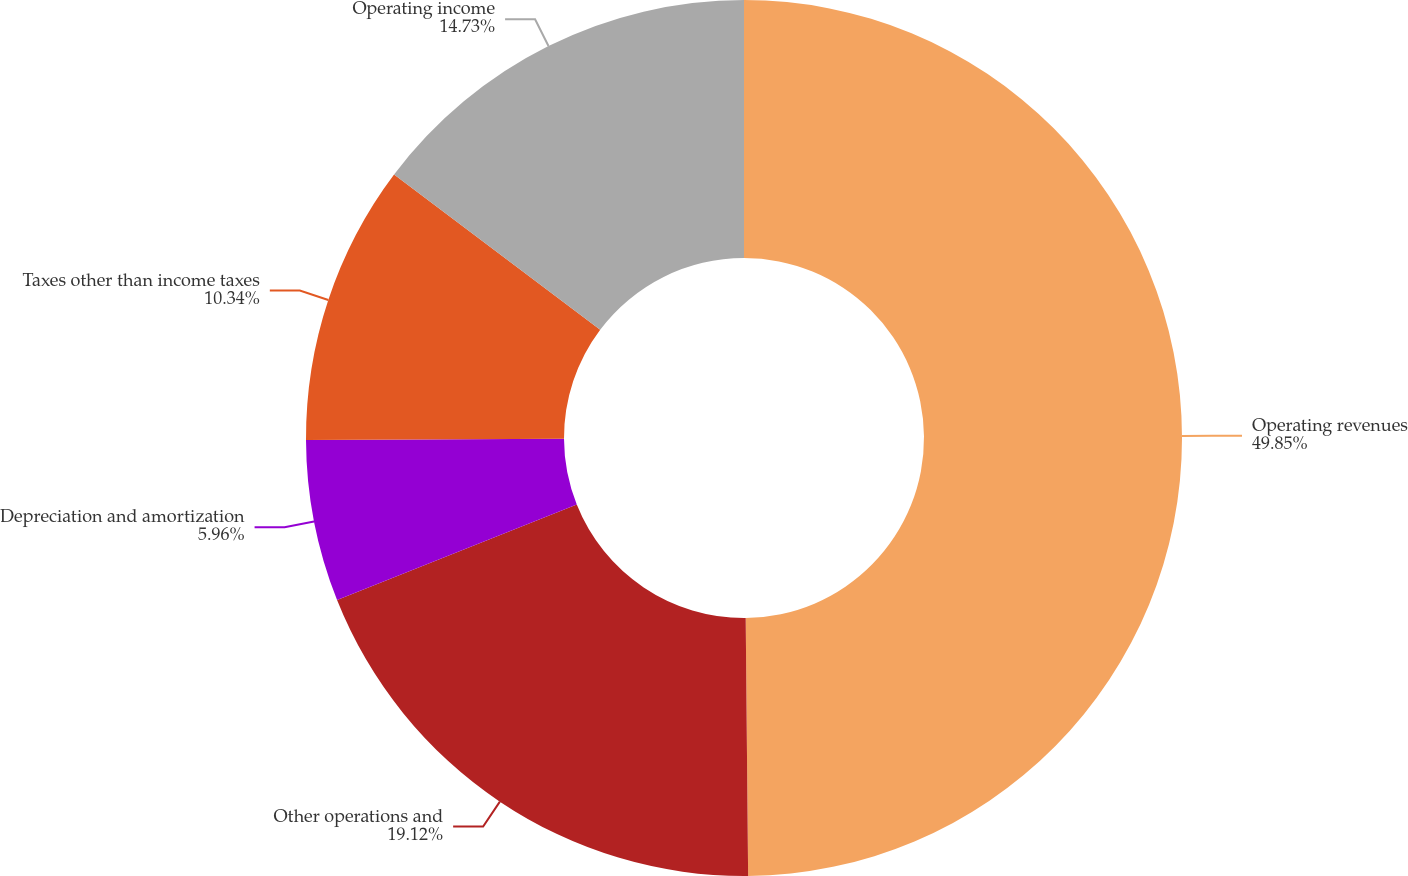<chart> <loc_0><loc_0><loc_500><loc_500><pie_chart><fcel>Operating revenues<fcel>Other operations and<fcel>Depreciation and amortization<fcel>Taxes other than income taxes<fcel>Operating income<nl><fcel>49.85%<fcel>19.12%<fcel>5.96%<fcel>10.34%<fcel>14.73%<nl></chart> 